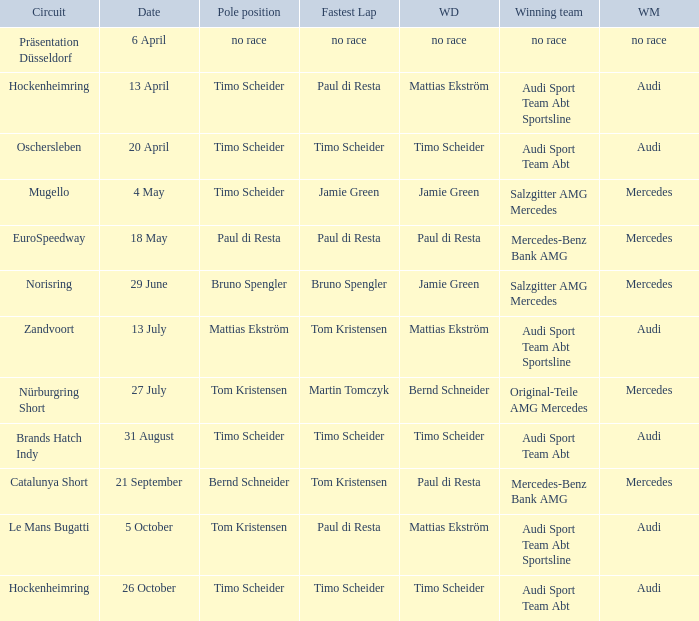Who is the winning driver of the race with no race as the winning manufacturer? No race. 